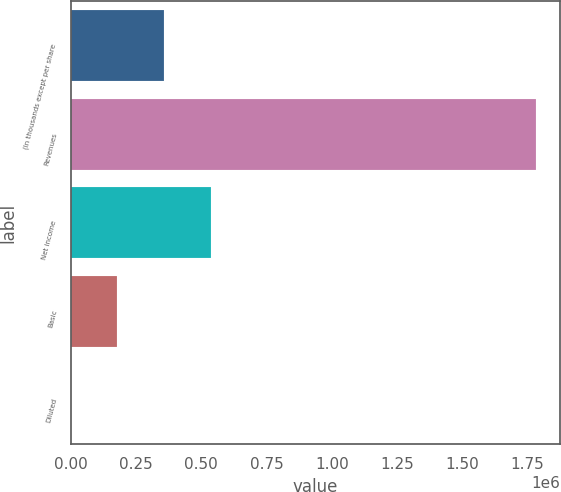Convert chart to OTSL. <chart><loc_0><loc_0><loc_500><loc_500><bar_chart><fcel>(In thousands except per share<fcel>Revenues<fcel>Net income<fcel>Basic<fcel>Diluted<nl><fcel>356886<fcel>1.78443e+06<fcel>535329<fcel>178444<fcel>0.83<nl></chart> 